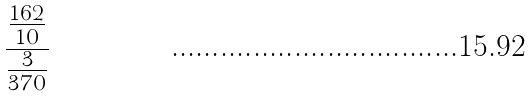<formula> <loc_0><loc_0><loc_500><loc_500>\frac { \frac { 1 6 2 } { 1 0 } } { \frac { 3 } { 3 7 0 } }</formula> 